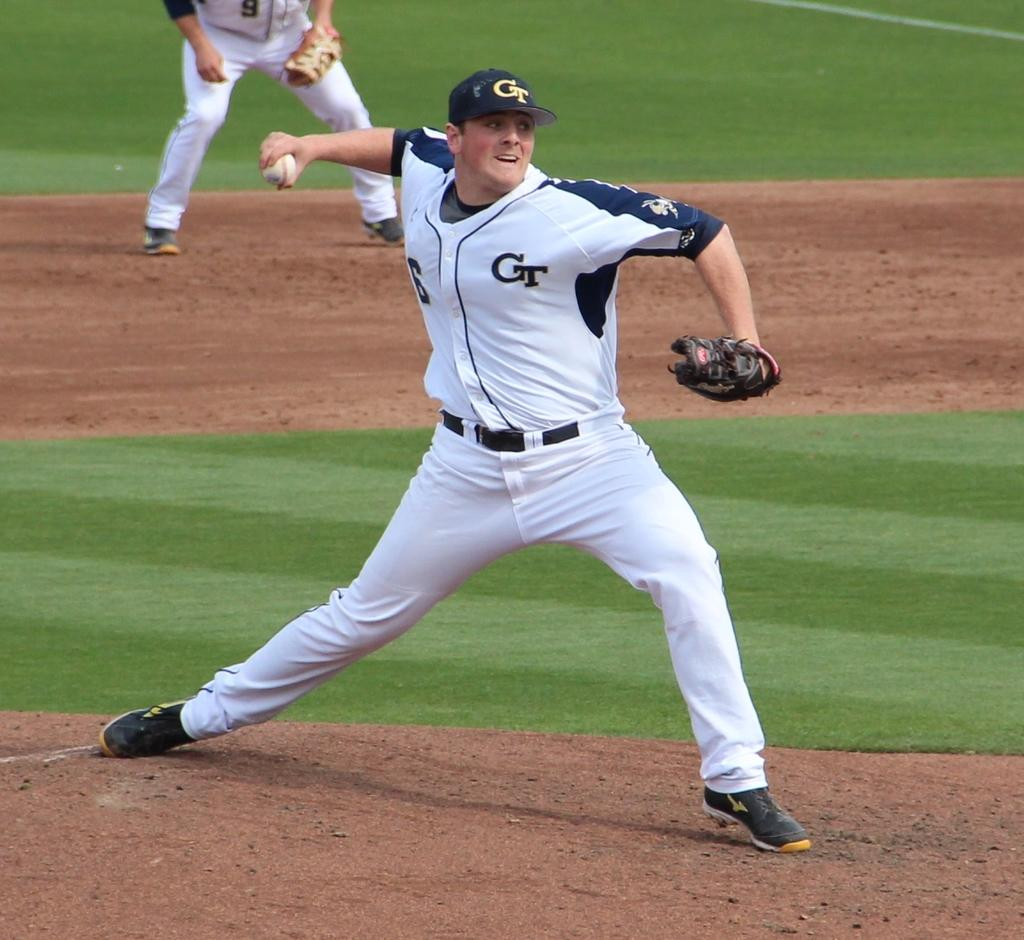<image>
Write a terse but informative summary of the picture. a baseball pitcher ready to throw a ball with CT on the uniform and the cap he's wearing. 